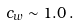<formula> <loc_0><loc_0><loc_500><loc_500>c _ { w } \sim 1 . 0 \, .</formula> 